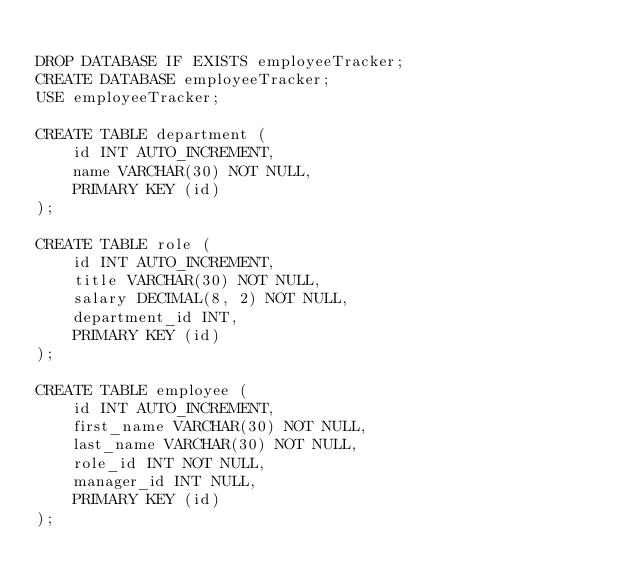<code> <loc_0><loc_0><loc_500><loc_500><_SQL_>
DROP DATABASE IF EXISTS employeeTracker;
CREATE DATABASE employeeTracker;
USE employeeTracker;

CREATE TABLE department (
	id INT AUTO_INCREMENT,
    name VARCHAR(30) NOT NULL,
    PRIMARY KEY (id)
);

CREATE TABLE role (
	id INT AUTO_INCREMENT,
    title VARCHAR(30) NOT NULL,
    salary DECIMAL(8, 2) NOT NULL,
    department_id INT,
    PRIMARY KEY (id)
);

CREATE TABLE employee (
	id INT AUTO_INCREMENT,
    first_name VARCHAR(30) NOT NULL,
    last_name VARCHAR(30) NOT NULL,
    role_id INT NOT NULL,
    manager_id INT NULL,
    PRIMARY KEY (id)
);</code> 